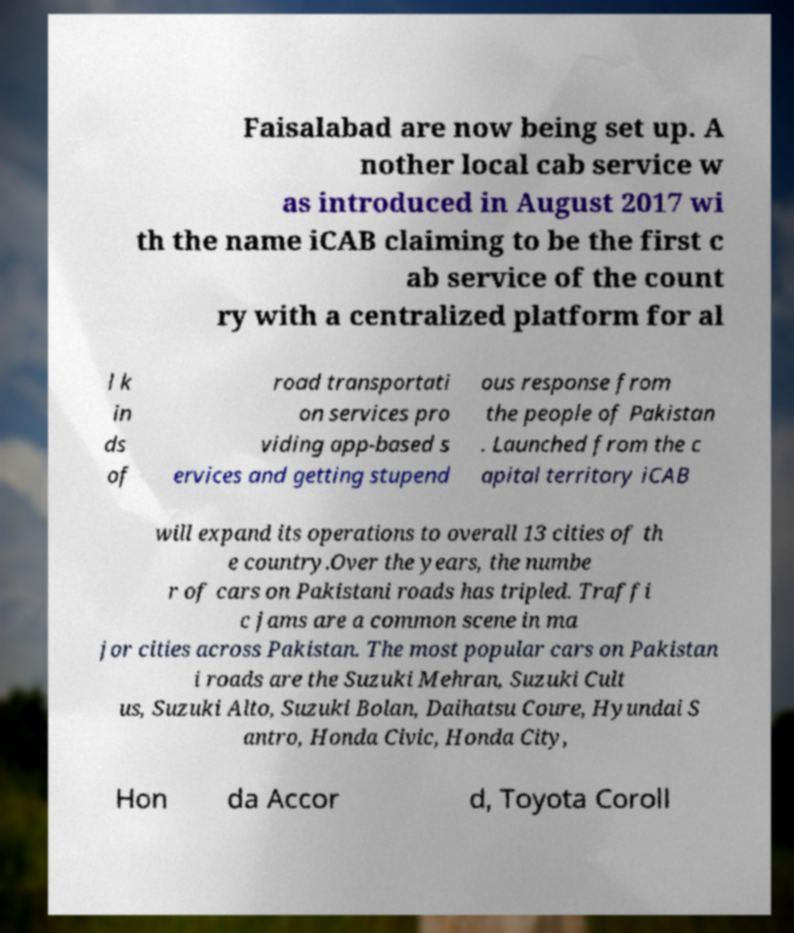Please read and relay the text visible in this image. What does it say? Faisalabad are now being set up. A nother local cab service w as introduced in August 2017 wi th the name iCAB claiming to be the first c ab service of the count ry with a centralized platform for al l k in ds of road transportati on services pro viding app-based s ervices and getting stupend ous response from the people of Pakistan . Launched from the c apital territory iCAB will expand its operations to overall 13 cities of th e country.Over the years, the numbe r of cars on Pakistani roads has tripled. Traffi c jams are a common scene in ma jor cities across Pakistan. The most popular cars on Pakistan i roads are the Suzuki Mehran, Suzuki Cult us, Suzuki Alto, Suzuki Bolan, Daihatsu Coure, Hyundai S antro, Honda Civic, Honda City, Hon da Accor d, Toyota Coroll 